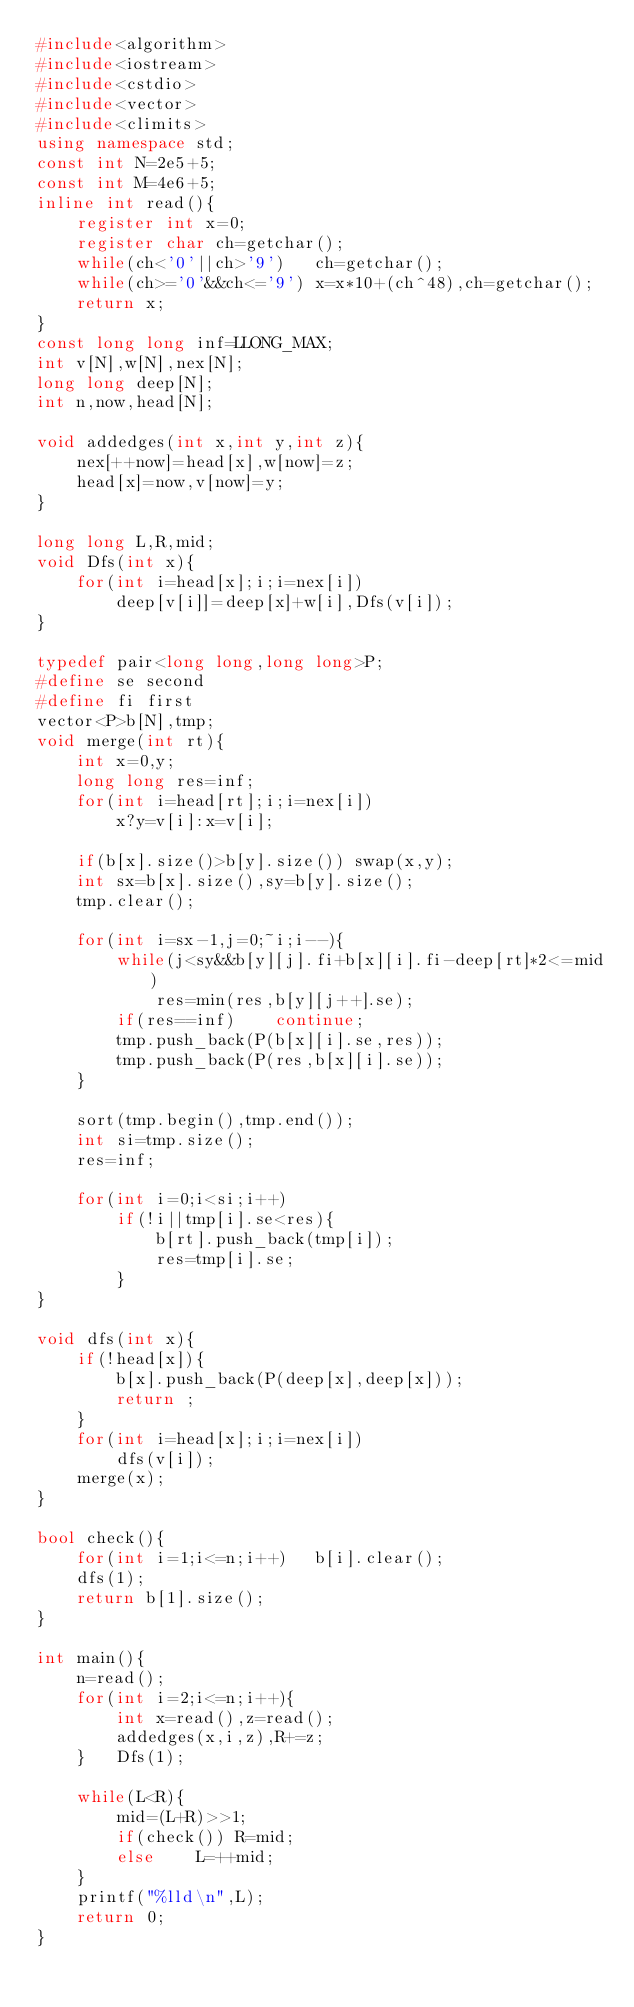<code> <loc_0><loc_0><loc_500><loc_500><_C++_>#include<algorithm>
#include<iostream>
#include<cstdio>
#include<vector>
#include<climits>
using namespace std;
const int N=2e5+5;
const int M=4e6+5;
inline int read(){
	register int x=0;
	register char ch=getchar();
	while(ch<'0'||ch>'9')	ch=getchar();
	while(ch>='0'&&ch<='9')	x=x*10+(ch^48),ch=getchar();
	return x;
}
const long long inf=LLONG_MAX;
int v[N],w[N],nex[N];
long long deep[N];
int n,now,head[N];

void addedges(int x,int y,int z){
	nex[++now]=head[x],w[now]=z;
	head[x]=now,v[now]=y;
}

long long L,R,mid;
void Dfs(int x){
	for(int i=head[x];i;i=nex[i])
		deep[v[i]]=deep[x]+w[i],Dfs(v[i]);
}

typedef pair<long long,long long>P;
#define se second
#define fi first
vector<P>b[N],tmp;
void merge(int rt){
	int x=0,y;
	long long res=inf;
	for(int i=head[rt];i;i=nex[i])
		x?y=v[i]:x=v[i];

	if(b[x].size()>b[y].size())	swap(x,y);
	int sx=b[x].size(),sy=b[y].size();
	tmp.clear();

	for(int i=sx-1,j=0;~i;i--){
		while(j<sy&&b[y][j].fi+b[x][i].fi-deep[rt]*2<=mid)
			res=min(res,b[y][j++].se);
		if(res==inf)	continue;
		tmp.push_back(P(b[x][i].se,res));
		tmp.push_back(P(res,b[x][i].se));
	}

	sort(tmp.begin(),tmp.end());
	int si=tmp.size();
	res=inf;

	for(int i=0;i<si;i++)
		if(!i||tmp[i].se<res){
			b[rt].push_back(tmp[i]);
			res=tmp[i].se;
		}
}

void dfs(int x){
	if(!head[x]){
		b[x].push_back(P(deep[x],deep[x]));
		return ;
	}
	for(int i=head[x];i;i=nex[i])
		dfs(v[i]);
	merge(x);
}

bool check(){
	for(int i=1;i<=n;i++)	b[i].clear();
	dfs(1);
	return b[1].size();
}

int main(){
	n=read();
	for(int i=2;i<=n;i++){
		int x=read(),z=read();
		addedges(x,i,z),R+=z;
	}	Dfs(1);

	while(L<R){
		mid=(L+R)>>1;
		if(check())	R=mid;
		else	L=++mid;
	}
	printf("%lld\n",L);
	return 0;
}
</code> 